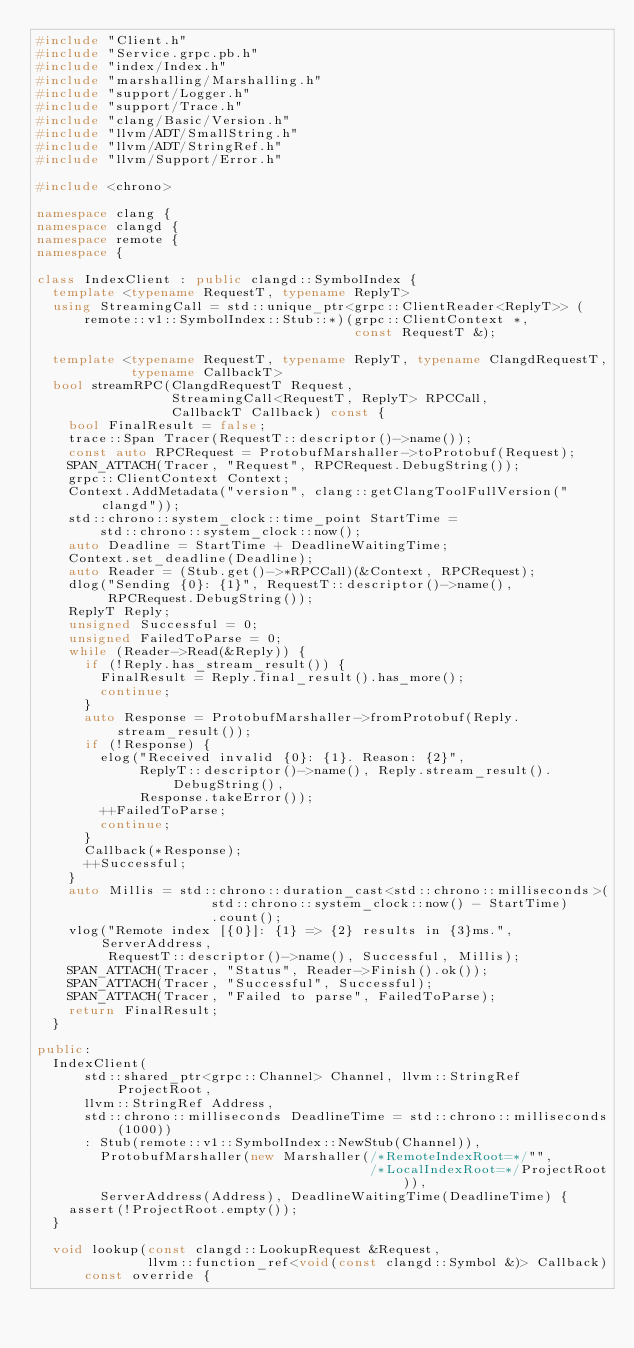Convert code to text. <code><loc_0><loc_0><loc_500><loc_500><_C++_>#include "Client.h"
#include "Service.grpc.pb.h"
#include "index/Index.h"
#include "marshalling/Marshalling.h"
#include "support/Logger.h"
#include "support/Trace.h"
#include "clang/Basic/Version.h"
#include "llvm/ADT/SmallString.h"
#include "llvm/ADT/StringRef.h"
#include "llvm/Support/Error.h"

#include <chrono>

namespace clang {
namespace clangd {
namespace remote {
namespace {

class IndexClient : public clangd::SymbolIndex {
  template <typename RequestT, typename ReplyT>
  using StreamingCall = std::unique_ptr<grpc::ClientReader<ReplyT>> (
      remote::v1::SymbolIndex::Stub::*)(grpc::ClientContext *,
                                        const RequestT &);

  template <typename RequestT, typename ReplyT, typename ClangdRequestT,
            typename CallbackT>
  bool streamRPC(ClangdRequestT Request,
                 StreamingCall<RequestT, ReplyT> RPCCall,
                 CallbackT Callback) const {
    bool FinalResult = false;
    trace::Span Tracer(RequestT::descriptor()->name());
    const auto RPCRequest = ProtobufMarshaller->toProtobuf(Request);
    SPAN_ATTACH(Tracer, "Request", RPCRequest.DebugString());
    grpc::ClientContext Context;
    Context.AddMetadata("version", clang::getClangToolFullVersion("clangd"));
    std::chrono::system_clock::time_point StartTime =
        std::chrono::system_clock::now();
    auto Deadline = StartTime + DeadlineWaitingTime;
    Context.set_deadline(Deadline);
    auto Reader = (Stub.get()->*RPCCall)(&Context, RPCRequest);
    dlog("Sending {0}: {1}", RequestT::descriptor()->name(),
         RPCRequest.DebugString());
    ReplyT Reply;
    unsigned Successful = 0;
    unsigned FailedToParse = 0;
    while (Reader->Read(&Reply)) {
      if (!Reply.has_stream_result()) {
        FinalResult = Reply.final_result().has_more();
        continue;
      }
      auto Response = ProtobufMarshaller->fromProtobuf(Reply.stream_result());
      if (!Response) {
        elog("Received invalid {0}: {1}. Reason: {2}",
             ReplyT::descriptor()->name(), Reply.stream_result().DebugString(),
             Response.takeError());
        ++FailedToParse;
        continue;
      }
      Callback(*Response);
      ++Successful;
    }
    auto Millis = std::chrono::duration_cast<std::chrono::milliseconds>(
                      std::chrono::system_clock::now() - StartTime)
                      .count();
    vlog("Remote index [{0}]: {1} => {2} results in {3}ms.", ServerAddress,
         RequestT::descriptor()->name(), Successful, Millis);
    SPAN_ATTACH(Tracer, "Status", Reader->Finish().ok());
    SPAN_ATTACH(Tracer, "Successful", Successful);
    SPAN_ATTACH(Tracer, "Failed to parse", FailedToParse);
    return FinalResult;
  }

public:
  IndexClient(
      std::shared_ptr<grpc::Channel> Channel, llvm::StringRef ProjectRoot,
      llvm::StringRef Address,
      std::chrono::milliseconds DeadlineTime = std::chrono::milliseconds(1000))
      : Stub(remote::v1::SymbolIndex::NewStub(Channel)),
        ProtobufMarshaller(new Marshaller(/*RemoteIndexRoot=*/"",
                                          /*LocalIndexRoot=*/ProjectRoot)),
        ServerAddress(Address), DeadlineWaitingTime(DeadlineTime) {
    assert(!ProjectRoot.empty());
  }

  void lookup(const clangd::LookupRequest &Request,
              llvm::function_ref<void(const clangd::Symbol &)> Callback)
      const override {</code> 